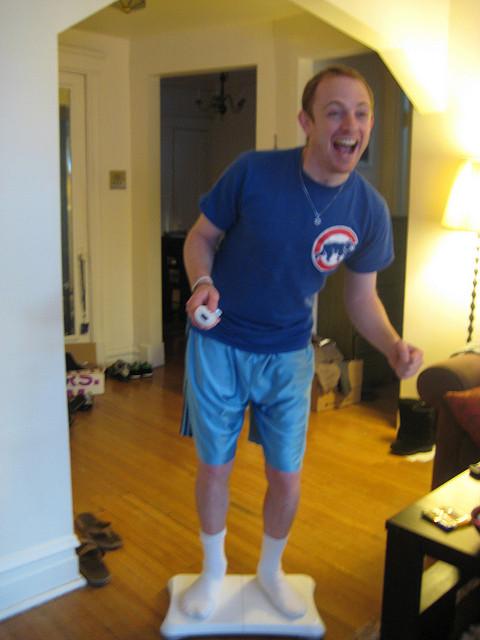What color is the bag on the floor?
Write a very short answer. White. What is the man standing on?
Keep it brief. Wii fit. Is the person wearing glasses?
Short answer required. No. Is he in a house?
Answer briefly. Yes. What is he standing on?
Quick response, please. Wii fit. What color are his shorts?
Answer briefly. Blue. 